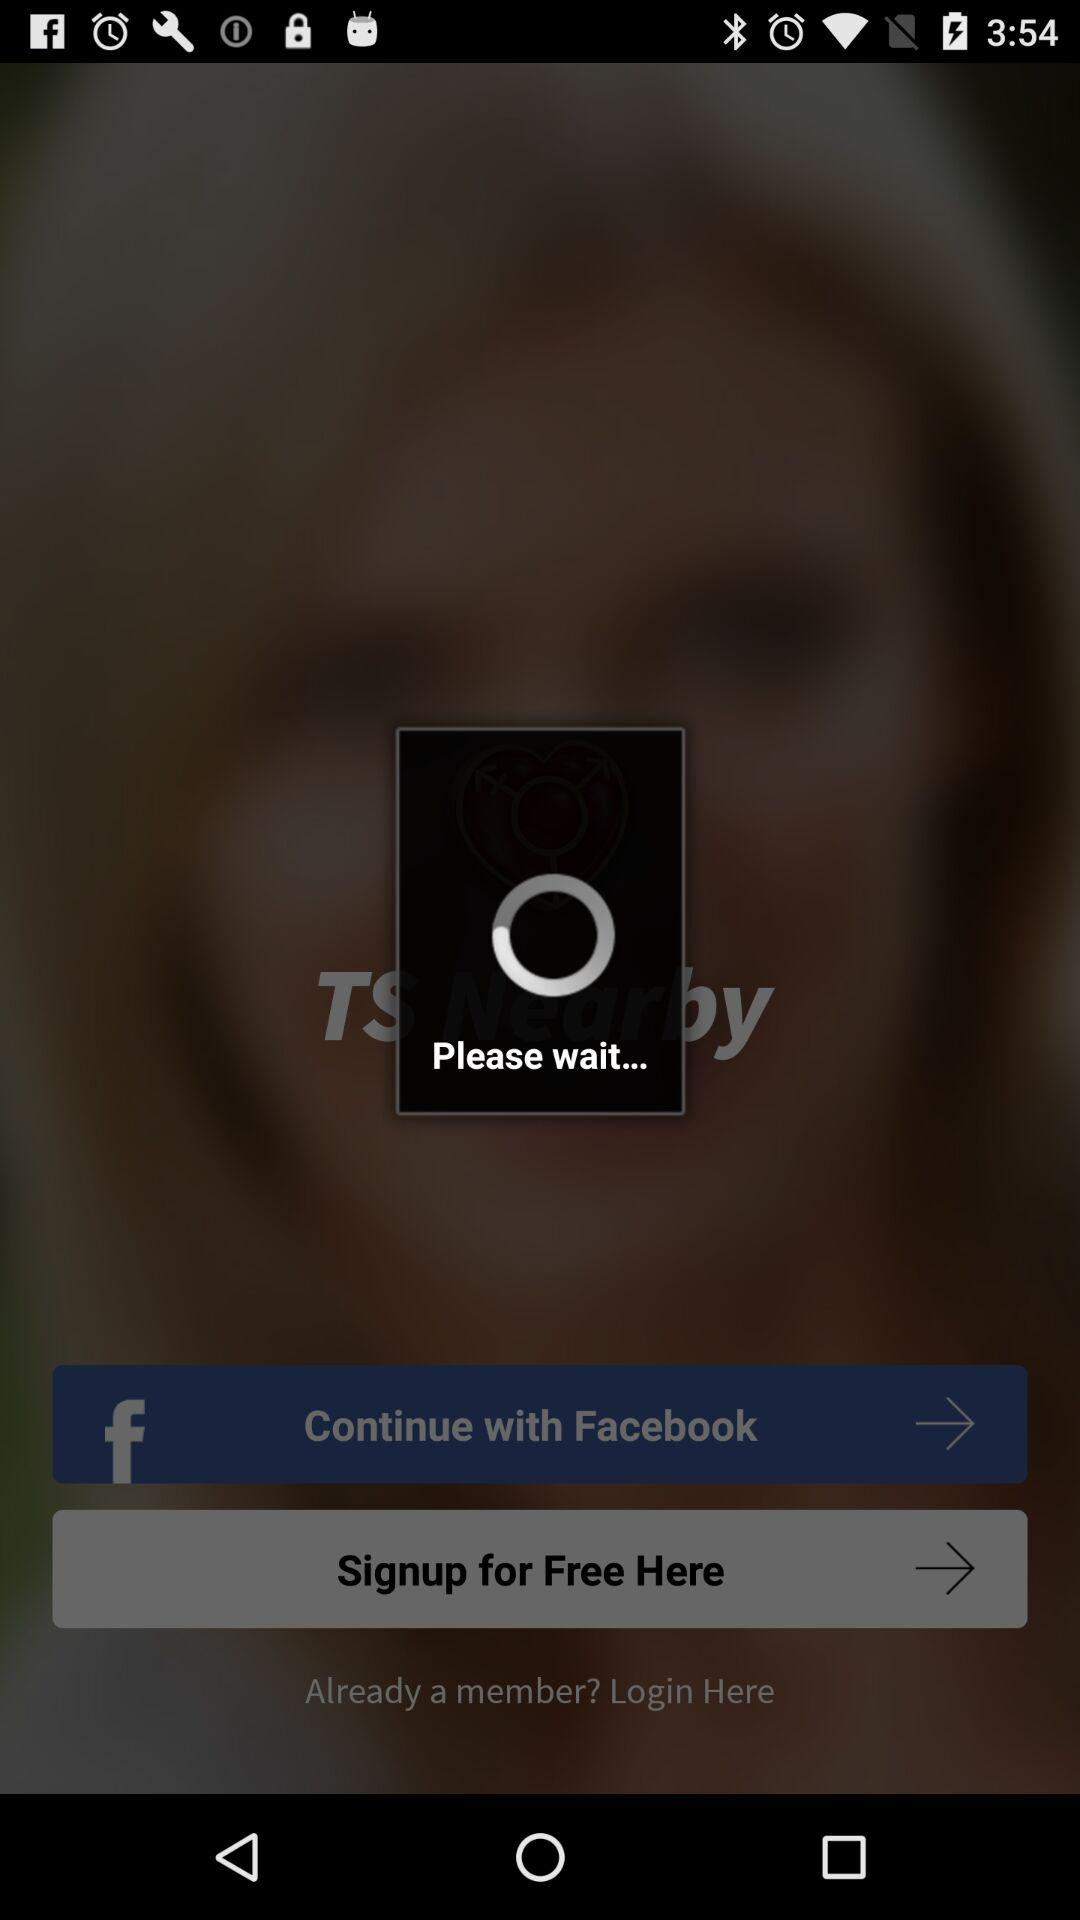How can we login?
When the provided information is insufficient, respond with <no answer>. <no answer> 